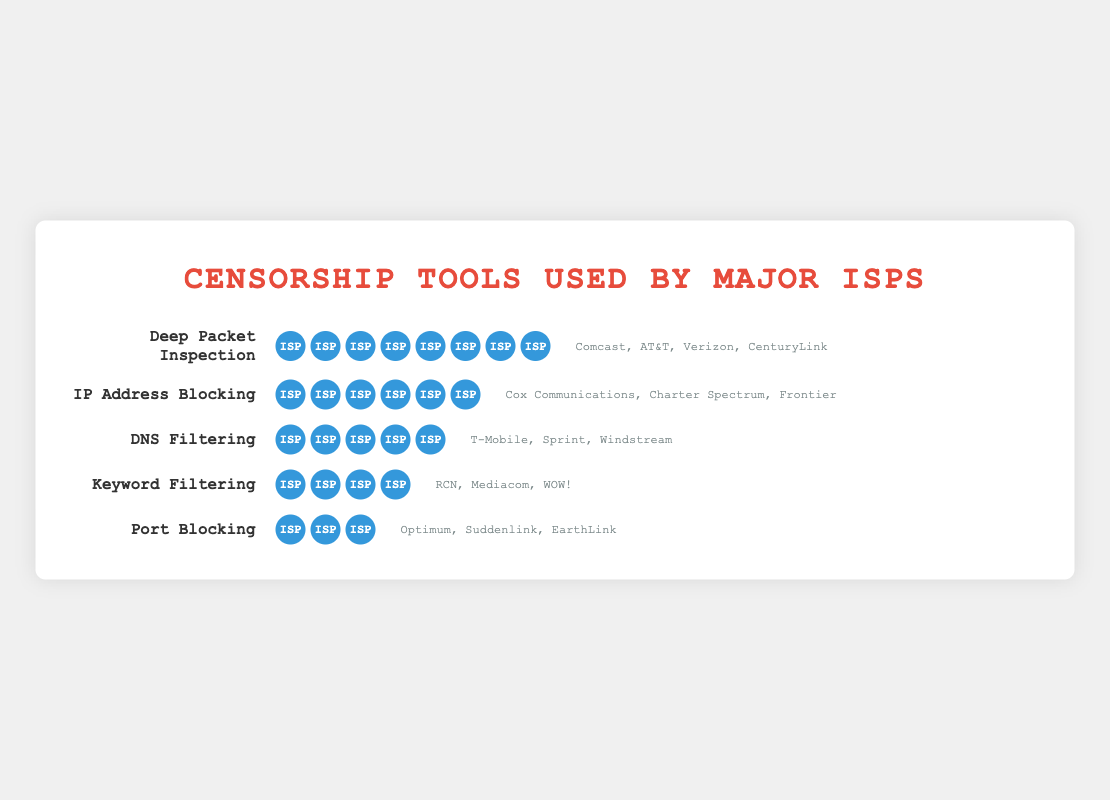What is the most commonly used censorship tool by major ISPs? The most commonly used censorship tool can be identified by looking for the tool with the highest count of icons. Deep Packet Inspection has 8 icons, indicating it is the most commonly used.
Answer: Deep Packet Inspection Which censorship tool has the least number of ISPs using it? To find the least used tool, look for the one with the smallest number of icons. Port Blocking has only 3 icons, making it the least used tool.
Answer: Port Blocking How many ISPs use DNS Filtering? Count the number of icons next to DNS Filtering. There are 5 icons present.
Answer: 5 Which ISPs are using IP Address Blocking? Look at the text next to the icons representing IP Address Blocking. The providers listed are Cox Communications, Charter Spectrum, and Frontier.
Answer: Cox Communications, Charter Spectrum, Frontier Compare the number of ISPs using Deep Packet Inspection and Keyword Filtering. Which is more widely used and by how many more ISPs? Count the number of icons for both Deep Packet Inspection (8) and Keyword Filtering (4). Deep Packet Inspection is used by 4 more ISPs.
Answer: Deep Packet Inspection by 4 more ISPs How many ISPs in total are represented in this figure? Sum the counts of all the different censorship tools: 8 (Deep Packet Inspection) + 6 (IP Address Blocking) + 5 (DNS Filtering) + 4 (Keyword Filtering) + 3 (Port Blocking) = 26. However, as some ISPs might use multiple tools, this is the total occurrences, not distinct ISPs.
Answer: 26 (total occurrences) Which censorship tools are used by more than 5 ISPs? Identify tools with a count greater than 5. Deep Packet Inspection (8) and IP Address Blocking (6) both meet this criterion.
Answer: Deep Packet Inspection, IP Address Blocking List the ISPs that use Keyword Filtering. Refer to the providers listed next to the icons for Keyword Filtering. The ISPs mentioned are RCN, Mediacom, and WOW!.
Answer: RCN, Mediacom, WOW! Is DNS Filtering more or less popular than IP Address Blocking? Compare the number of icons for DNS Filtering and IP Address Blocking. DNS Filtering has 5 icons whereas IP Address Blocking has 6 icons; hence, DNS Filtering is less popular.
Answer: Less popular What is the total number of different censorship tools used by all ISPs? Count the number of different censorship tools listed. There are 5 types of tools.
Answer: 5 